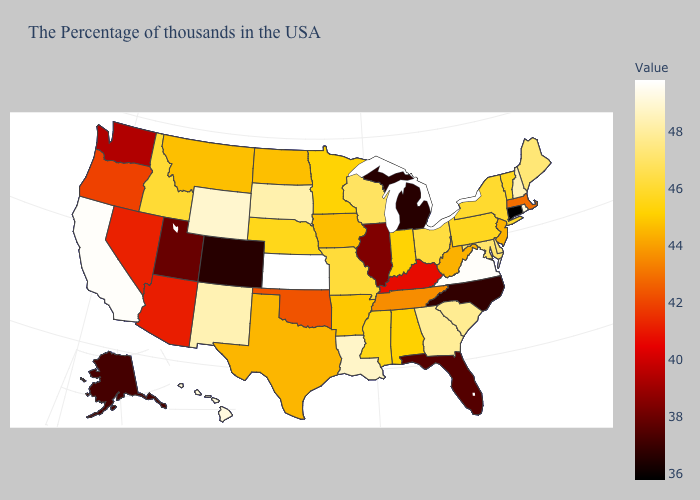Which states have the lowest value in the MidWest?
Write a very short answer. Michigan. Does North Carolina have the lowest value in the USA?
Concise answer only. No. Does Oklahoma have a lower value than Montana?
Quick response, please. Yes. Which states have the lowest value in the MidWest?
Be succinct. Michigan. Does Connecticut have the lowest value in the USA?
Concise answer only. Yes. Does the map have missing data?
Concise answer only. No. Does Pennsylvania have the highest value in the USA?
Write a very short answer. No. 